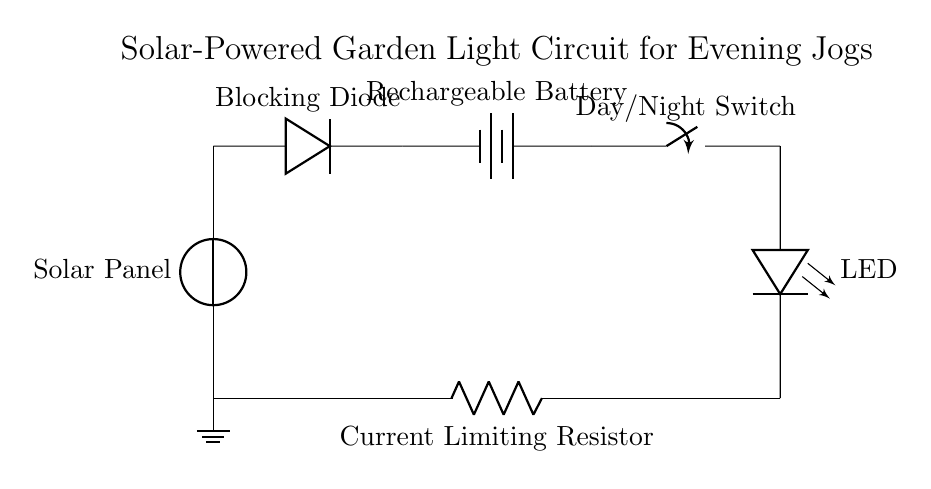What is the role of the blocking diode? The blocking diode prevents reverse current flow from the battery to the solar panel, allowing current only to flow from the panel to the battery.
Answer: Prevent reverse current What type of battery is used in this circuit? The circuit uses a rechargeable battery, which is necessary to collect energy from the solar panel and store it for later use during the night.
Answer: Rechargeable battery What component limits the current to the LED? The current limiting resistor is designed to restrict the flow of current to the LED, ensuring it operates within safe limits and does not get damaged.
Answer: Current limiting resistor How many main components are in the circuit? The circuit contains five main components: solar panel, blocking diode, rechargeable battery, switch, and LED.
Answer: Five components What happens when the day/night switch is closed? When the day/night switch is closed, it allows power to flow from the battery to the LED, illuminating the garden light. This switch controls whether the LED is on or off based on light conditions.
Answer: LED illuminates What is the purpose of the solar panel in this circuit? The solar panel converts sunlight into electrical energy, which is used to charge the rechargeable battery during the day when sunlight is available.
Answer: Convert sunlight to energy 